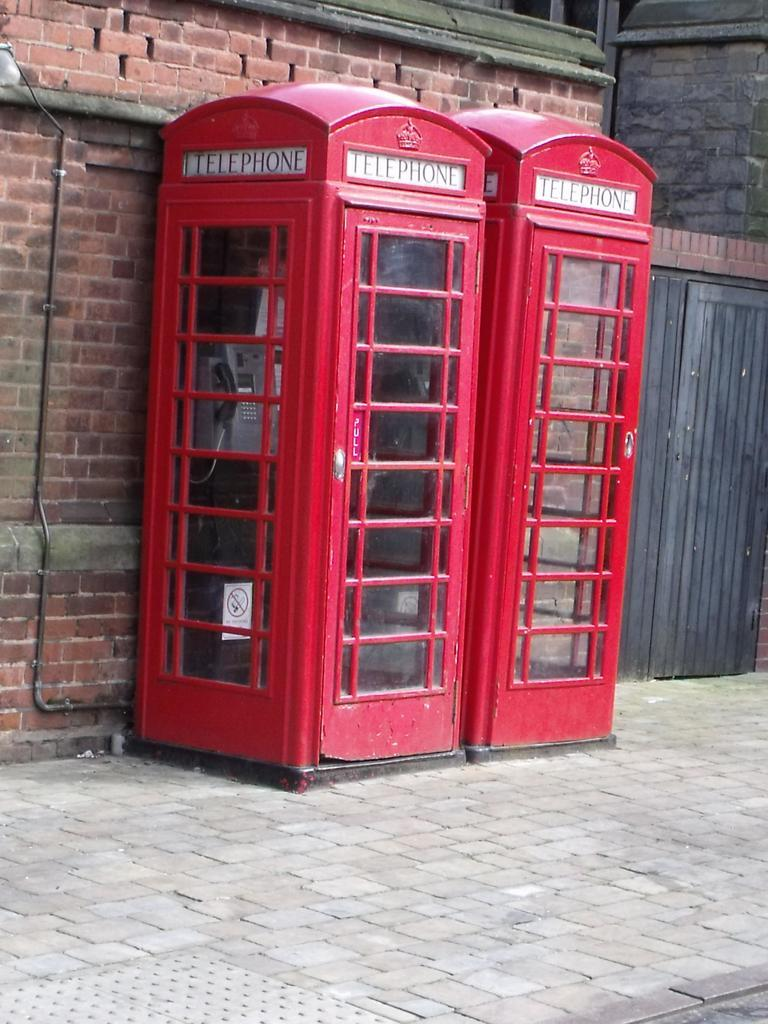<image>
Render a clear and concise summary of the photo. Two telephone booths in bright red occupy part of the brick sidewalk. 